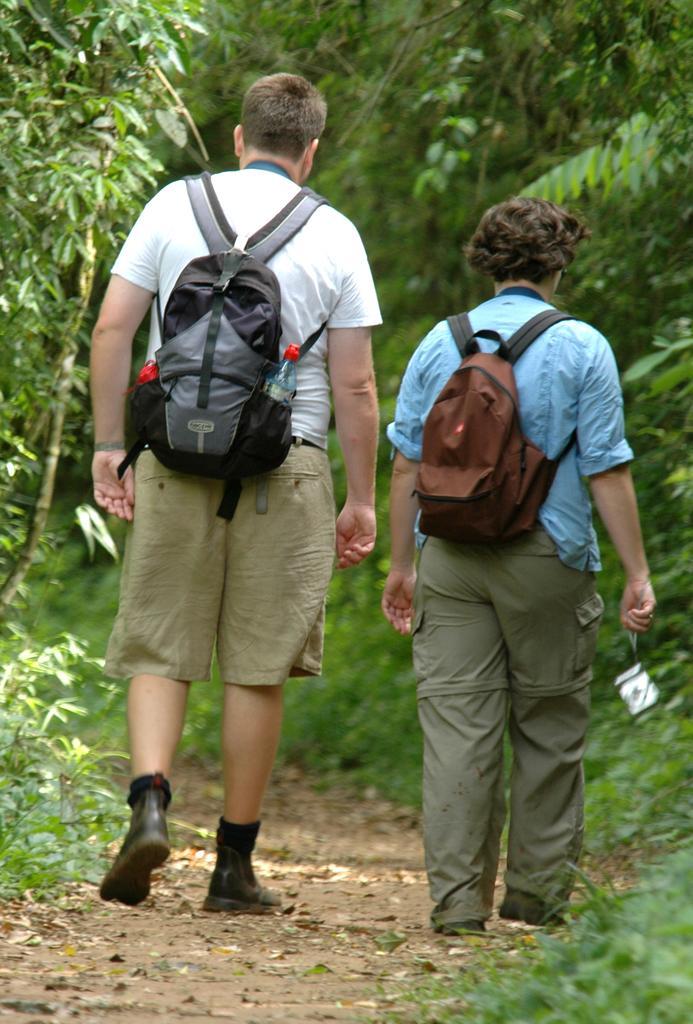Describe this image in one or two sentences. These two persons are walking, as there is a leg movement and wore bags. In this bag there is a bottle. We can able to see trees in-front of them. 